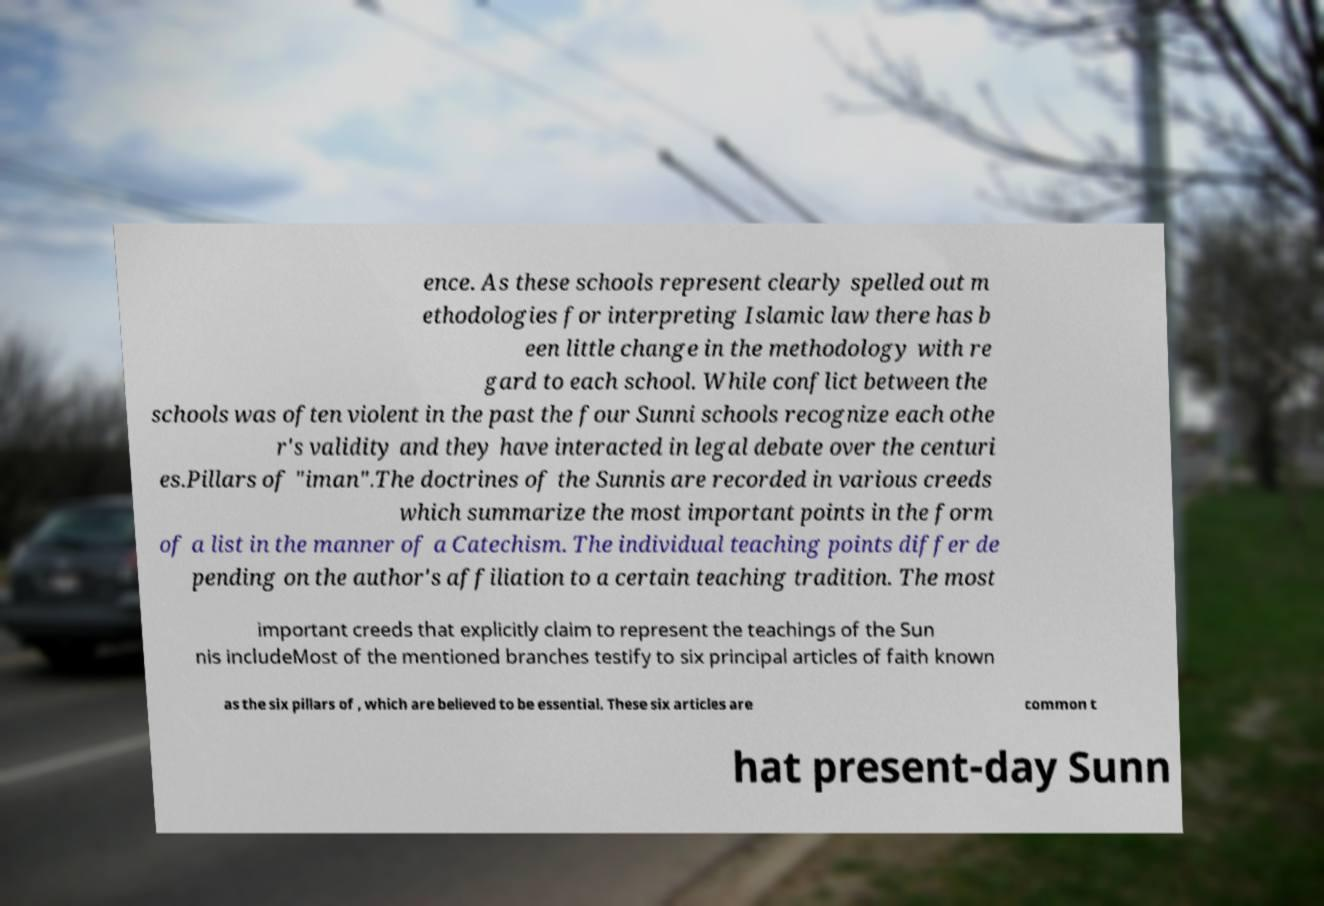For documentation purposes, I need the text within this image transcribed. Could you provide that? ence. As these schools represent clearly spelled out m ethodologies for interpreting Islamic law there has b een little change in the methodology with re gard to each school. While conflict between the schools was often violent in the past the four Sunni schools recognize each othe r's validity and they have interacted in legal debate over the centuri es.Pillars of "iman".The doctrines of the Sunnis are recorded in various creeds which summarize the most important points in the form of a list in the manner of a Catechism. The individual teaching points differ de pending on the author's affiliation to a certain teaching tradition. The most important creeds that explicitly claim to represent the teachings of the Sun nis includeMost of the mentioned branches testify to six principal articles of faith known as the six pillars of , which are believed to be essential. These six articles are common t hat present-day Sunn 